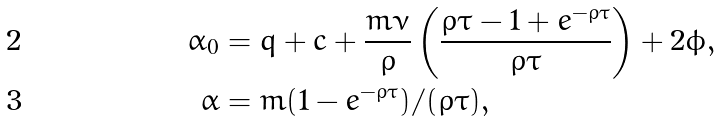Convert formula to latex. <formula><loc_0><loc_0><loc_500><loc_500>\alpha _ { 0 } & = q + \bar { c } + \frac { m \nu } { \varrho } \left ( \frac { \varrho \bar { \tau } - 1 + e ^ { - \varrho \bar { \tau } } } { \varrho \bar { \tau } } \right ) + 2 \phi , \\ \alpha & = m ( 1 - e ^ { - \varrho \bar { \tau } } ) / ( \varrho \bar { \tau } ) ,</formula> 